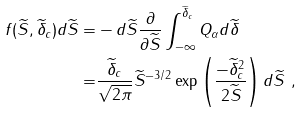<formula> <loc_0><loc_0><loc_500><loc_500>f ( \widetilde { S } , \widetilde { \delta } _ { c } ) d \widetilde { S } = & - d \widetilde { S } \frac { \partial } { \partial \widetilde { S } } \int _ { - \infty } ^ { \widetilde { \delta } _ { c } } Q _ { \alpha } d \widetilde { \delta } \\ = & \frac { \widetilde { \delta } _ { c } } { \sqrt { 2 \pi } } \widetilde { S } ^ { - 3 / 2 } \exp \left ( \frac { - \widetilde { \delta } _ { c } ^ { 2 } } { 2 \widetilde { S } } \right ) d \widetilde { S } \ ,</formula> 